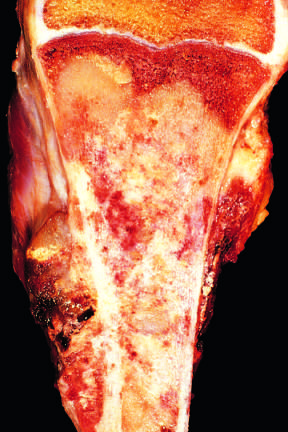what fills most of the medullary cavity of the metaphysis and proximal diaphysis?
Answer the question using a single word or phrase. The tan-white tumor 